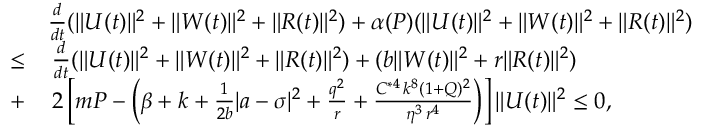<formula> <loc_0><loc_0><loc_500><loc_500>\begin{array} { r l } & { \frac { d } { d t } ( \| U ( t ) \| ^ { 2 } + \| W ( t ) \| ^ { 2 } + \| R ( t ) \| ^ { 2 } ) + \alpha ( P ) ( \| U ( t ) \| ^ { 2 } + \| W ( t ) \| ^ { 2 } + \| R ( t ) \| ^ { 2 } ) } \\ { \leq } & { \, \frac { d } { d t } ( \| U ( t ) \| ^ { 2 } + \| W ( t ) \| ^ { 2 } + \| R ( t ) \| ^ { 2 } ) + ( b \| W ( t ) \| ^ { 2 } + r \| R ( t ) \| ^ { 2 } ) } \\ { + } & { \, 2 \left [ m P - \left ( \beta + k + \frac { 1 } { 2 b } | a - \sigma | ^ { 2 } + \frac { q ^ { 2 } } { r } + \frac { C ^ { * 4 } \, k ^ { 8 } ( 1 + Q ) ^ { 2 } } { \eta ^ { 3 } \, r ^ { 4 } } \right ) \right ] \| U ( t ) \| ^ { 2 } \leq 0 , } \end{array}</formula> 